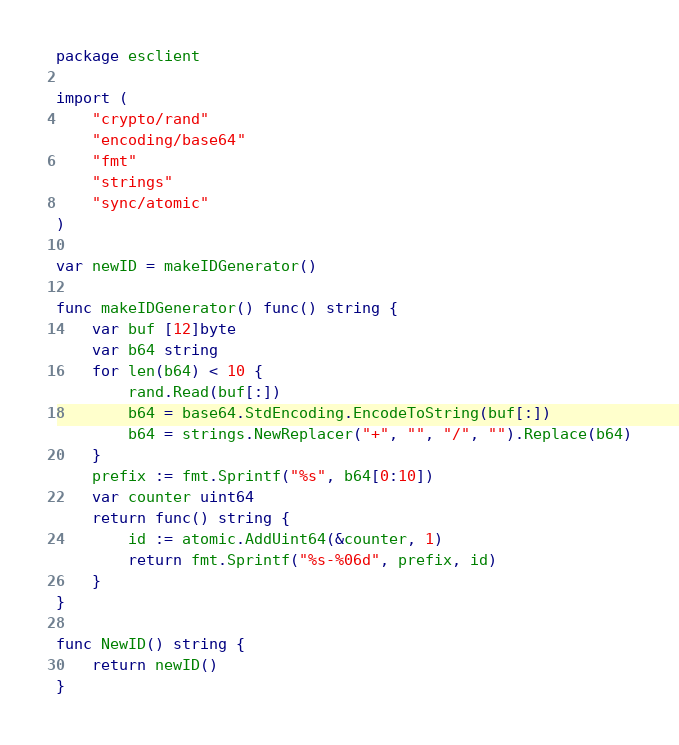Convert code to text. <code><loc_0><loc_0><loc_500><loc_500><_Go_>package esclient

import (
	"crypto/rand"
	"encoding/base64"
	"fmt"
	"strings"
	"sync/atomic"
)

var newID = makeIDGenerator()

func makeIDGenerator() func() string {
	var buf [12]byte
	var b64 string
	for len(b64) < 10 {
		rand.Read(buf[:])
		b64 = base64.StdEncoding.EncodeToString(buf[:])
		b64 = strings.NewReplacer("+", "", "/", "").Replace(b64)
	}
	prefix := fmt.Sprintf("%s", b64[0:10])
	var counter uint64
	return func() string {
		id := atomic.AddUint64(&counter, 1)
		return fmt.Sprintf("%s-%06d", prefix, id)
	}
}

func NewID() string {
	return newID()
}
</code> 